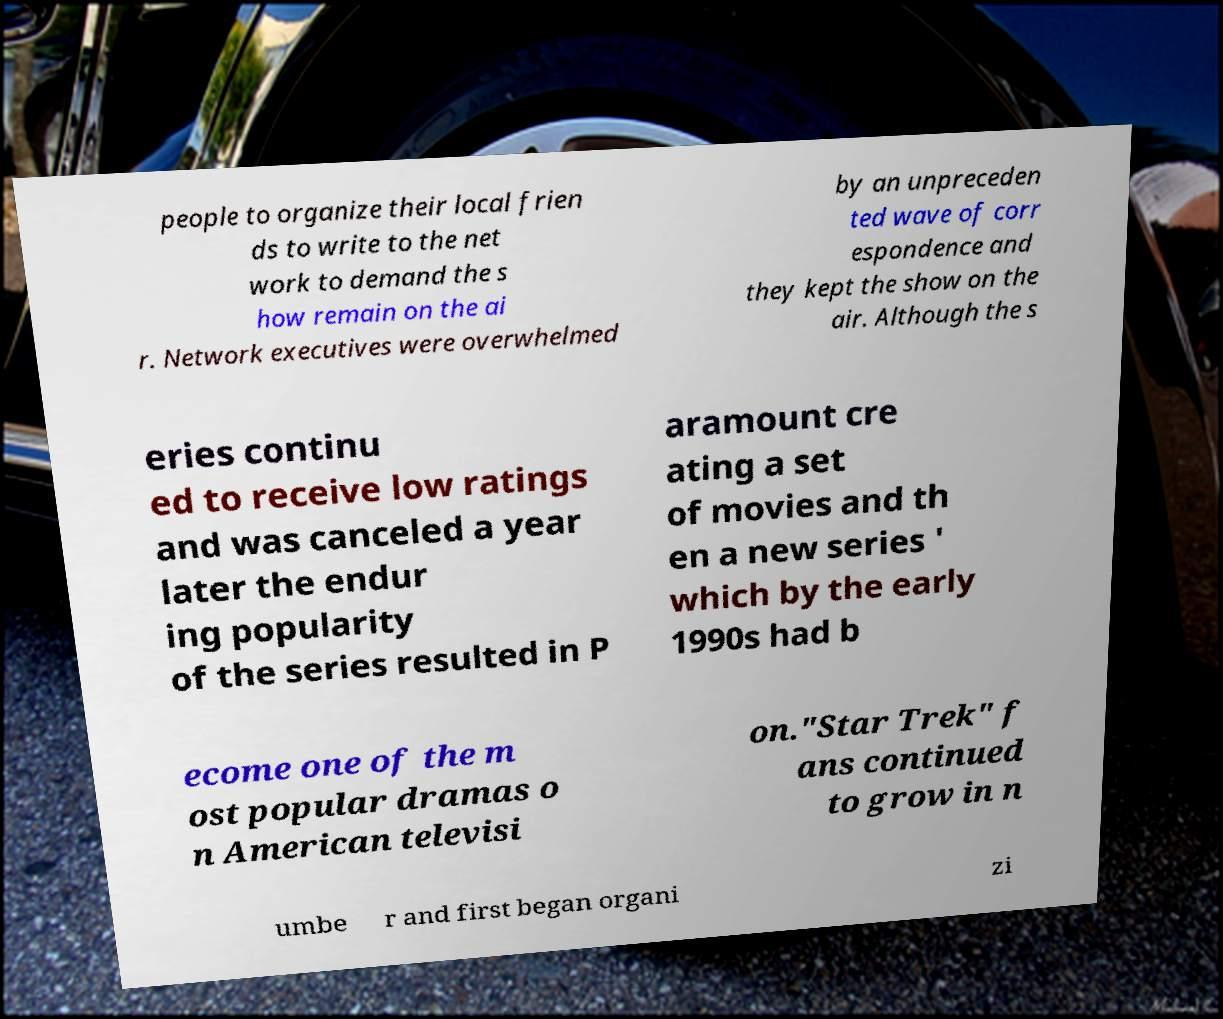Can you read and provide the text displayed in the image?This photo seems to have some interesting text. Can you extract and type it out for me? people to organize their local frien ds to write to the net work to demand the s how remain on the ai r. Network executives were overwhelmed by an unpreceden ted wave of corr espondence and they kept the show on the air. Although the s eries continu ed to receive low ratings and was canceled a year later the endur ing popularity of the series resulted in P aramount cre ating a set of movies and th en a new series ' which by the early 1990s had b ecome one of the m ost popular dramas o n American televisi on."Star Trek" f ans continued to grow in n umbe r and first began organi zi 